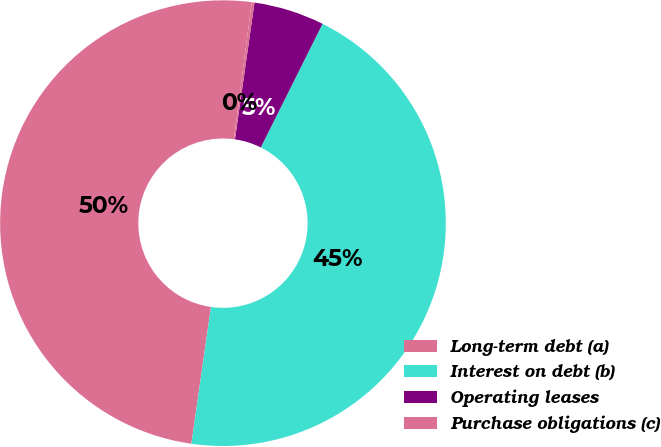Convert chart to OTSL. <chart><loc_0><loc_0><loc_500><loc_500><pie_chart><fcel>Long-term debt (a)<fcel>Interest on debt (b)<fcel>Operating leases<fcel>Purchase obligations (c)<nl><fcel>49.8%<fcel>44.89%<fcel>5.11%<fcel>0.2%<nl></chart> 